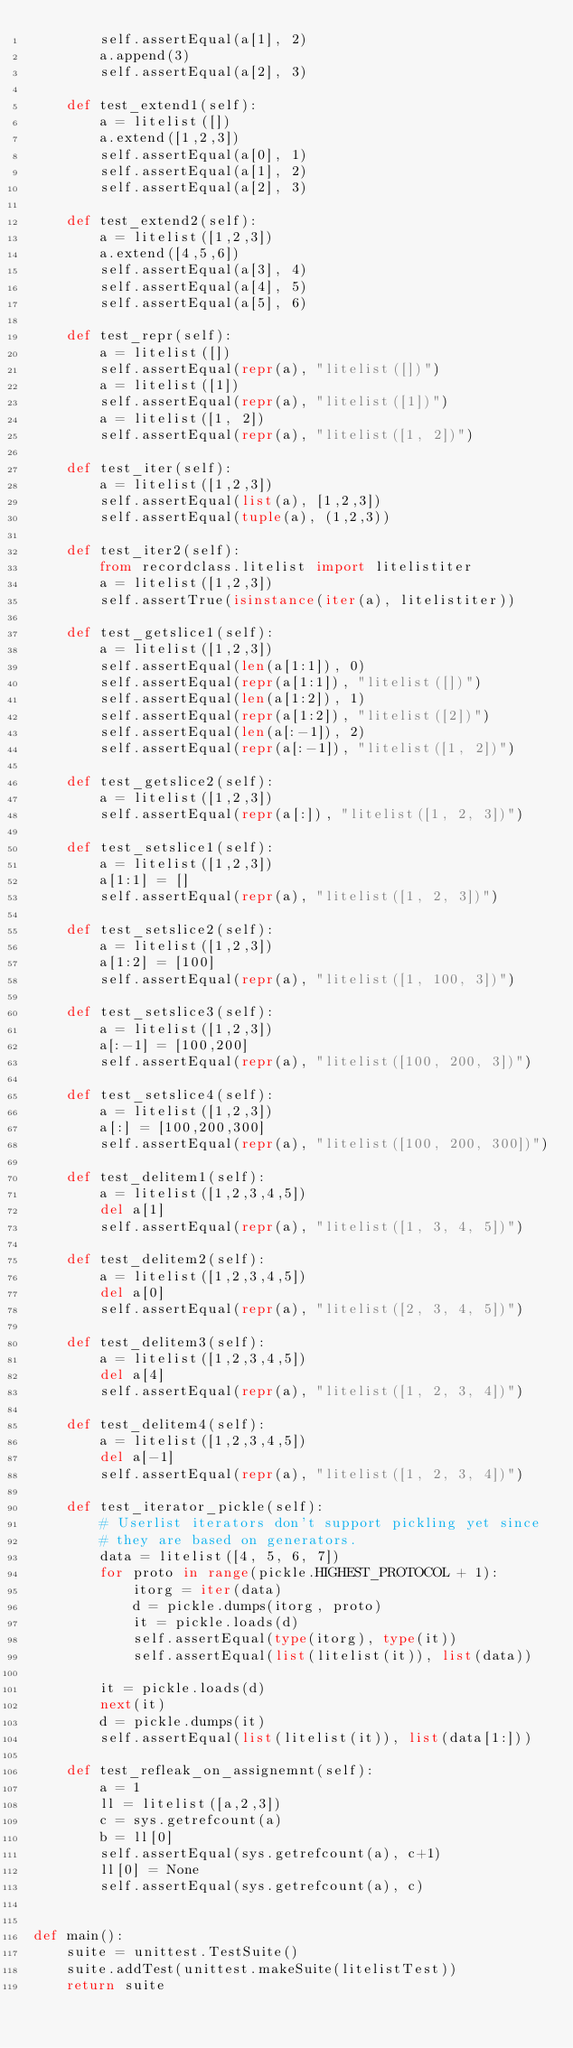Convert code to text. <code><loc_0><loc_0><loc_500><loc_500><_Python_>        self.assertEqual(a[1], 2)
        a.append(3)
        self.assertEqual(a[2], 3)

    def test_extend1(self):
        a = litelist([])
        a.extend([1,2,3])
        self.assertEqual(a[0], 1)
        self.assertEqual(a[1], 2)
        self.assertEqual(a[2], 3)

    def test_extend2(self):
        a = litelist([1,2,3])
        a.extend([4,5,6])
        self.assertEqual(a[3], 4)
        self.assertEqual(a[4], 5)
        self.assertEqual(a[5], 6)
        
    def test_repr(self):
        a = litelist([])
        self.assertEqual(repr(a), "litelist([])")
        a = litelist([1])
        self.assertEqual(repr(a), "litelist([1])")
        a = litelist([1, 2])
        self.assertEqual(repr(a), "litelist([1, 2])")

    def test_iter(self):
        a = litelist([1,2,3])
        self.assertEqual(list(a), [1,2,3])
        self.assertEqual(tuple(a), (1,2,3))

    def test_iter2(self):
        from recordclass.litelist import litelistiter
        a = litelist([1,2,3])
        self.assertTrue(isinstance(iter(a), litelistiter))        

    def test_getslice1(self):
        a = litelist([1,2,3])
        self.assertEqual(len(a[1:1]), 0)
        self.assertEqual(repr(a[1:1]), "litelist([])")
        self.assertEqual(len(a[1:2]), 1)
        self.assertEqual(repr(a[1:2]), "litelist([2])")
        self.assertEqual(len(a[:-1]), 2)
        self.assertEqual(repr(a[:-1]), "litelist([1, 2])")

    def test_getslice2(self):
        a = litelist([1,2,3])
        self.assertEqual(repr(a[:]), "litelist([1, 2, 3])")

    def test_setslice1(self):
        a = litelist([1,2,3])
        a[1:1] = []
        self.assertEqual(repr(a), "litelist([1, 2, 3])")

    def test_setslice2(self):
        a = litelist([1,2,3])
        a[1:2] = [100]
        self.assertEqual(repr(a), "litelist([1, 100, 3])")

    def test_setslice3(self):
        a = litelist([1,2,3])
        a[:-1] = [100,200]
        self.assertEqual(repr(a), "litelist([100, 200, 3])")

    def test_setslice4(self):
        a = litelist([1,2,3])
        a[:] = [100,200,300]
        self.assertEqual(repr(a), "litelist([100, 200, 300])")
        
    def test_delitem1(self):
        a = litelist([1,2,3,4,5])
        del a[1]
        self.assertEqual(repr(a), "litelist([1, 3, 4, 5])")

    def test_delitem2(self):
        a = litelist([1,2,3,4,5])
        del a[0]
        self.assertEqual(repr(a), "litelist([2, 3, 4, 5])")

    def test_delitem3(self):
        a = litelist([1,2,3,4,5])
        del a[4]
        self.assertEqual(repr(a), "litelist([1, 2, 3, 4])")

    def test_delitem4(self):
        a = litelist([1,2,3,4,5])
        del a[-1]
        self.assertEqual(repr(a), "litelist([1, 2, 3, 4])")
        
    def test_iterator_pickle(self):
        # Userlist iterators don't support pickling yet since
        # they are based on generators.
        data = litelist([4, 5, 6, 7])
        for proto in range(pickle.HIGHEST_PROTOCOL + 1):
            itorg = iter(data)
            d = pickle.dumps(itorg, proto)
            it = pickle.loads(d)
            self.assertEqual(type(itorg), type(it))
            self.assertEqual(list(litelist(it)), list(data))

        it = pickle.loads(d)
        next(it)
        d = pickle.dumps(it)
        self.assertEqual(list(litelist(it)), list(data[1:]))

    def test_refleak_on_assignemnt(self):
        a = 1
        ll = litelist([a,2,3])
        c = sys.getrefcount(a)
        b = ll[0]
        self.assertEqual(sys.getrefcount(a), c+1)
        ll[0] = None        
        self.assertEqual(sys.getrefcount(a), c)
        
        
def main():
    suite = unittest.TestSuite()
    suite.addTest(unittest.makeSuite(litelistTest))
    return suite

</code> 